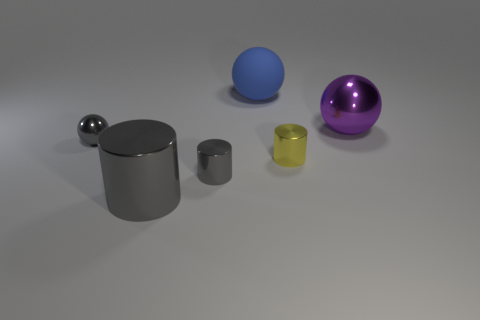Subtract all metallic spheres. How many spheres are left? 1 Subtract all yellow cylinders. How many cylinders are left? 2 Add 4 gray metal things. How many objects exist? 10 Subtract 1 cylinders. How many cylinders are left? 2 Subtract all yellow spheres. Subtract all green blocks. How many spheres are left? 3 Subtract all red cylinders. How many purple balls are left? 1 Subtract all red cubes. Subtract all gray shiny spheres. How many objects are left? 5 Add 1 large balls. How many large balls are left? 3 Add 1 brown cylinders. How many brown cylinders exist? 1 Subtract 1 blue spheres. How many objects are left? 5 